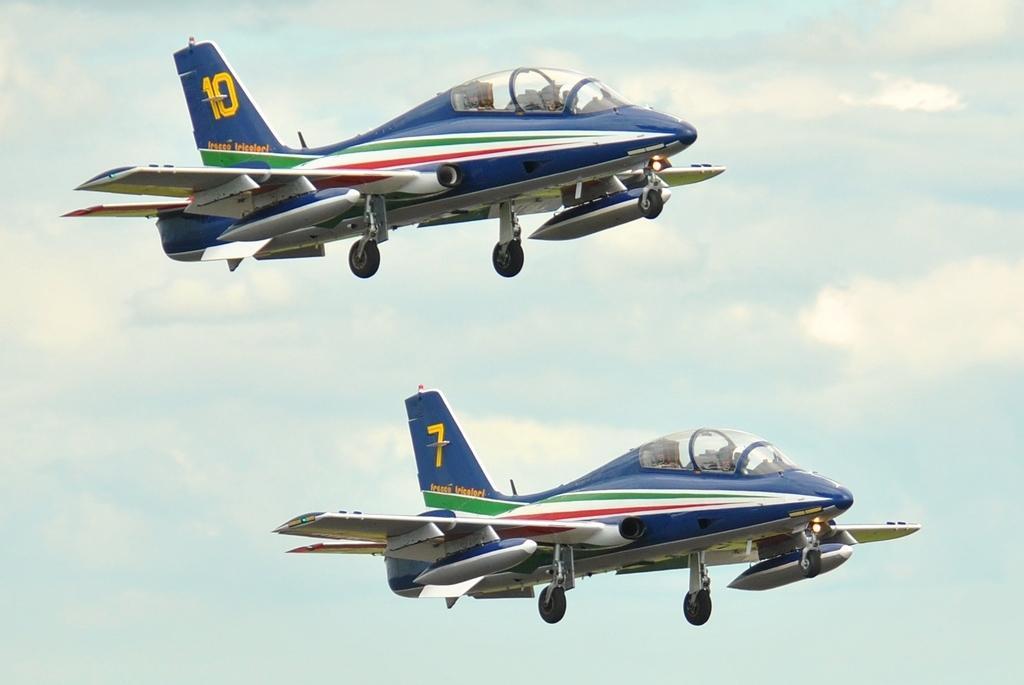Could you give a brief overview of what you see in this image? In this picture we can see the airplanes. In the background of the image we can see the clouds are present in the sky. 